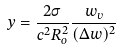Convert formula to latex. <formula><loc_0><loc_0><loc_500><loc_500>y = \frac { 2 \sigma } { c ^ { 2 } R _ { o } ^ { 2 } } \frac { w _ { v } } { ( \Delta w ) ^ { 2 } }</formula> 